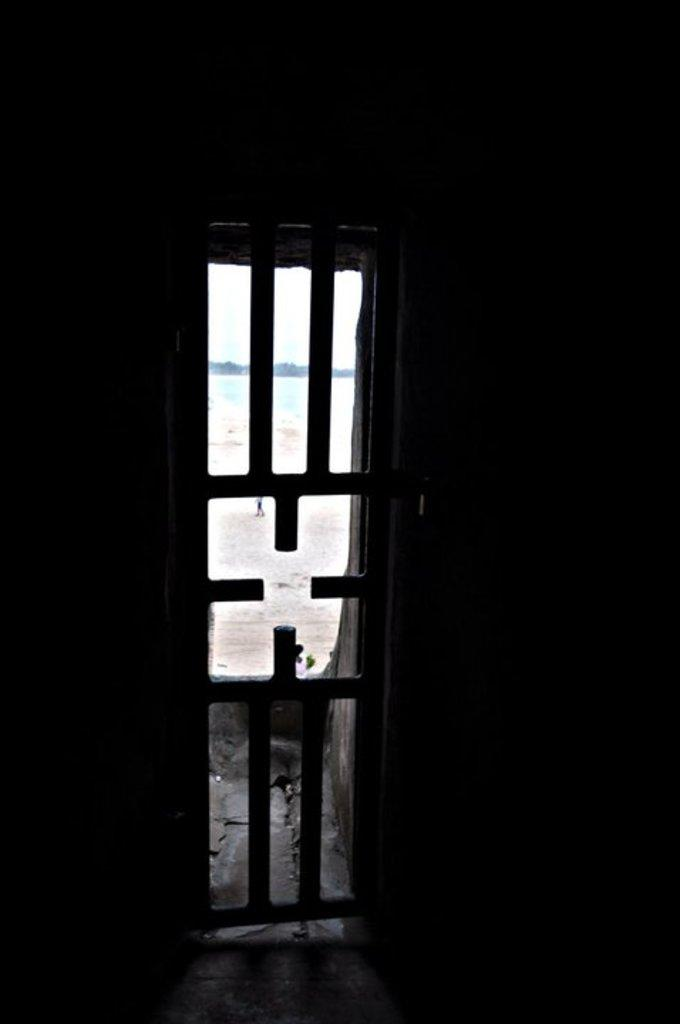What is present in the image that allows for a view of the outdoors? There is a window in the image that allows for a view of the outdoors. What type of structure is visible in the image? There is a wall in the image. What can be seen through the window in the image? Sand is visible behind the window. What type of wind can be seen blowing through the vase in the image? There is no vase present in the image, and therefore no wind blowing through it. 